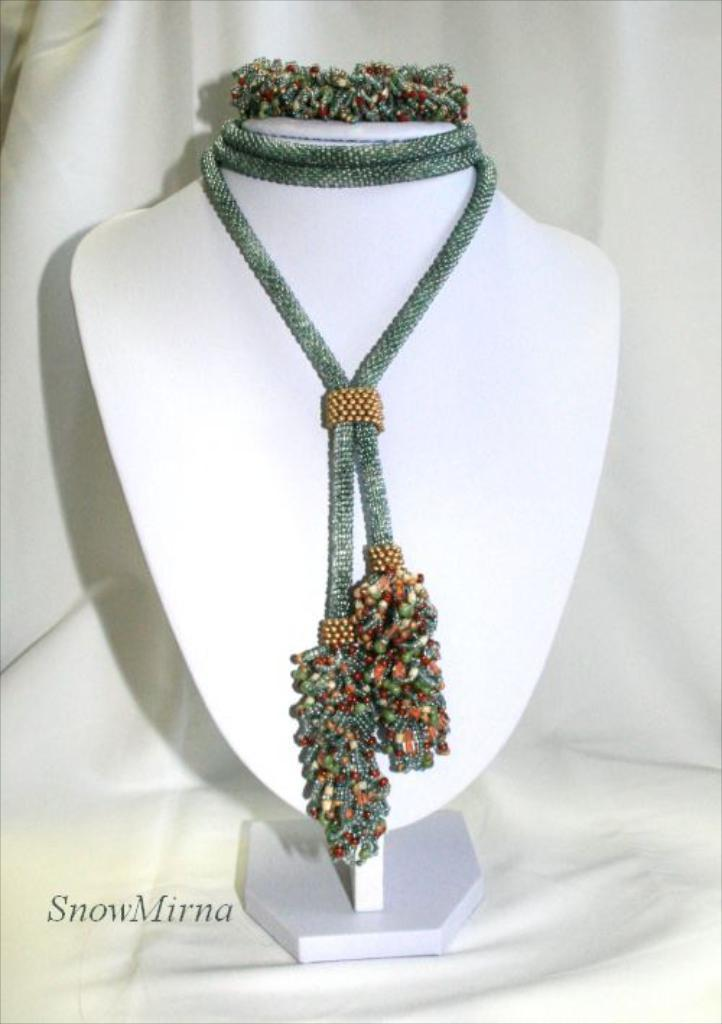What type of object is the main subject of the image? There is a jewelry ornament in the image. What type of notebook is being used to write about the star on the cart in the image? There is no notebook, star, or cart present in the image; it only features a jewelry ornament. 